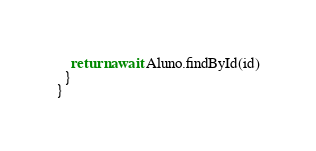Convert code to text. <code><loc_0><loc_0><loc_500><loc_500><_TypeScript_>    return await Aluno.findById(id)
  }
}</code> 